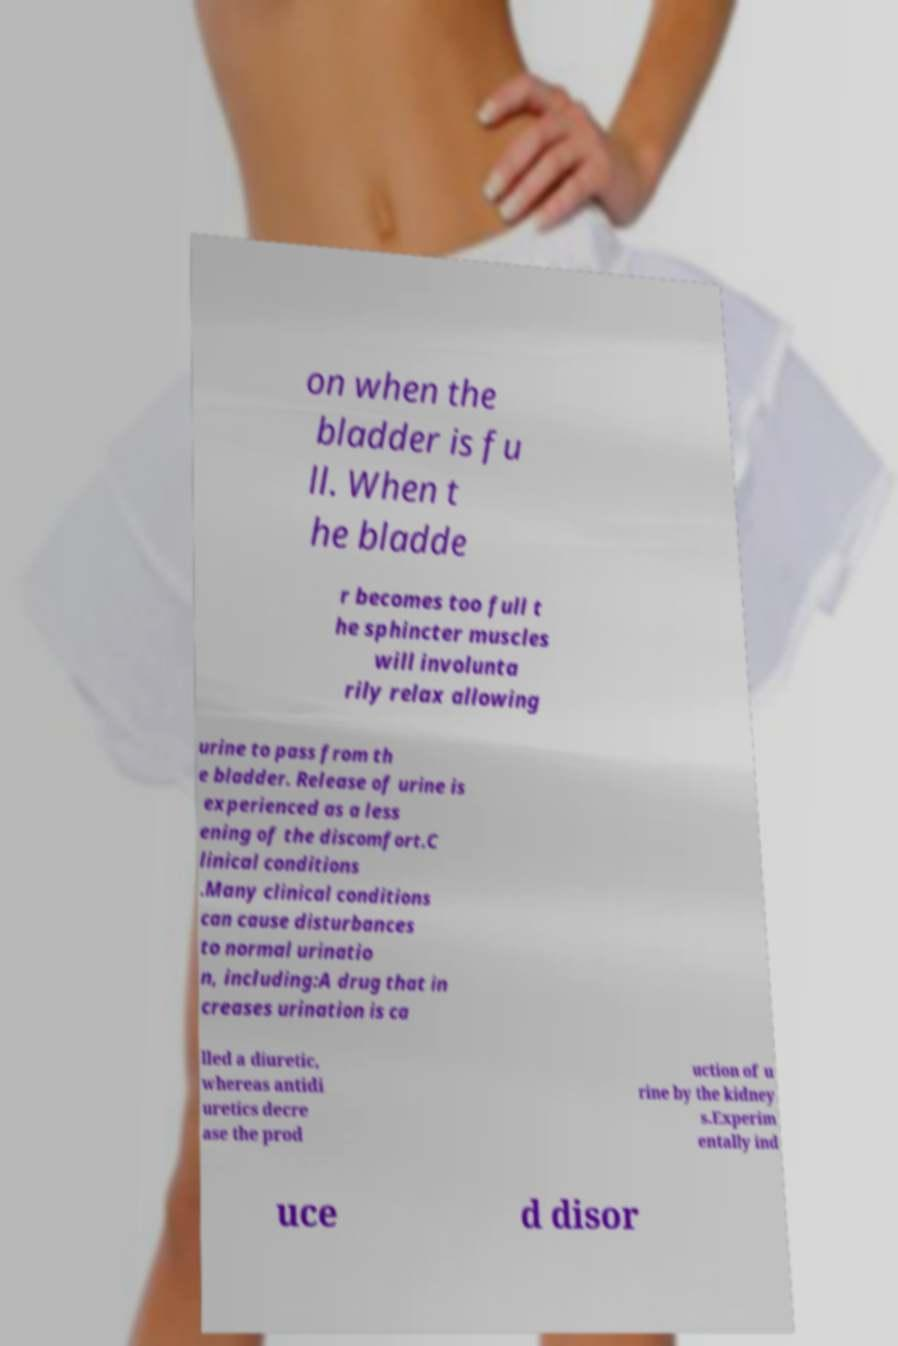Can you read and provide the text displayed in the image?This photo seems to have some interesting text. Can you extract and type it out for me? on when the bladder is fu ll. When t he bladde r becomes too full t he sphincter muscles will involunta rily relax allowing urine to pass from th e bladder. Release of urine is experienced as a less ening of the discomfort.C linical conditions .Many clinical conditions can cause disturbances to normal urinatio n, including:A drug that in creases urination is ca lled a diuretic, whereas antidi uretics decre ase the prod uction of u rine by the kidney s.Experim entally ind uce d disor 